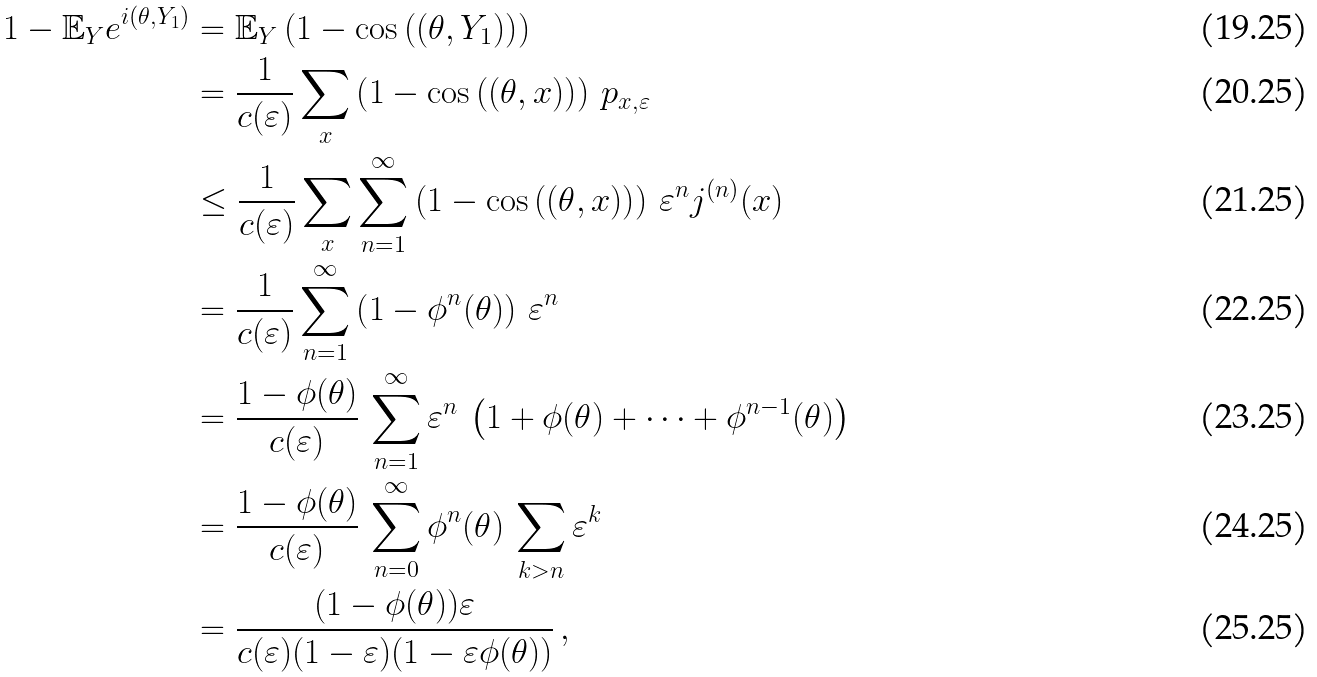<formula> <loc_0><loc_0><loc_500><loc_500>1 - { \mathbb { E } } _ { Y } e ^ { i ( \theta , Y _ { 1 } ) } & = { \mathbb { E } } _ { Y } \left ( 1 - \cos \left ( ( \theta , Y _ { 1 } ) \right ) \right ) \\ & = \frac { 1 } { c ( \varepsilon ) } \sum _ { x } \left ( 1 - \cos \left ( ( \theta , x ) \right ) \right ) \, p _ { x , \varepsilon } \\ & \leq \frac { 1 } { c ( \varepsilon ) } \sum _ { x } \sum _ { n = 1 } ^ { \infty } \left ( 1 - \cos \left ( ( \theta , x ) \right ) \right ) \, \varepsilon ^ { n } j ^ { ( n ) } ( x ) \\ & = \frac { 1 } { c ( \varepsilon ) } \sum _ { n = 1 } ^ { \infty } \left ( 1 - \phi ^ { n } ( \theta ) \right ) \, \varepsilon ^ { n } \\ & = \frac { 1 - \phi ( \theta ) } { c ( \varepsilon ) } \, \sum _ { n = 1 } ^ { \infty } \varepsilon ^ { n } \, \left ( 1 + \phi ( \theta ) + \dots + \phi ^ { n - 1 } ( \theta ) \right ) \\ & = \frac { 1 - \phi ( \theta ) } { c ( \varepsilon ) } \, \sum _ { n = 0 } ^ { \infty } \phi ^ { n } ( \theta ) \, \sum _ { k > n } \varepsilon ^ { k } \\ & = \frac { ( 1 - \phi ( \theta ) ) \varepsilon } { c ( \varepsilon ) ( 1 - \varepsilon ) ( 1 - \varepsilon \phi ( \theta ) ) } \, ,</formula> 